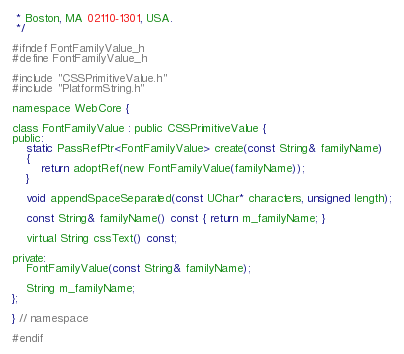<code> <loc_0><loc_0><loc_500><loc_500><_C_> * Boston, MA 02110-1301, USA.
 */

#ifndef FontFamilyValue_h
#define FontFamilyValue_h

#include "CSSPrimitiveValue.h"
#include "PlatformString.h"

namespace WebCore {

class FontFamilyValue : public CSSPrimitiveValue {
public:
    static PassRefPtr<FontFamilyValue> create(const String& familyName)
    {
        return adoptRef(new FontFamilyValue(familyName));
    }

    void appendSpaceSeparated(const UChar* characters, unsigned length);

    const String& familyName() const { return m_familyName; }

    virtual String cssText() const;

private:
    FontFamilyValue(const String& familyName);

    String m_familyName;
};

} // namespace

#endif
</code> 